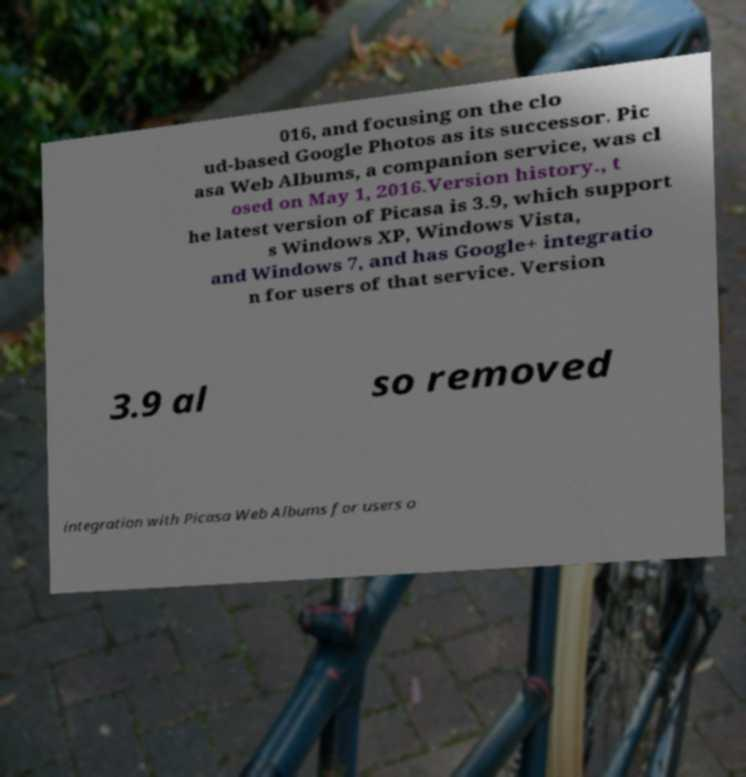For documentation purposes, I need the text within this image transcribed. Could you provide that? 016, and focusing on the clo ud-based Google Photos as its successor. Pic asa Web Albums, a companion service, was cl osed on May 1, 2016.Version history., t he latest version of Picasa is 3.9, which support s Windows XP, Windows Vista, and Windows 7, and has Google+ integratio n for users of that service. Version 3.9 al so removed integration with Picasa Web Albums for users o 